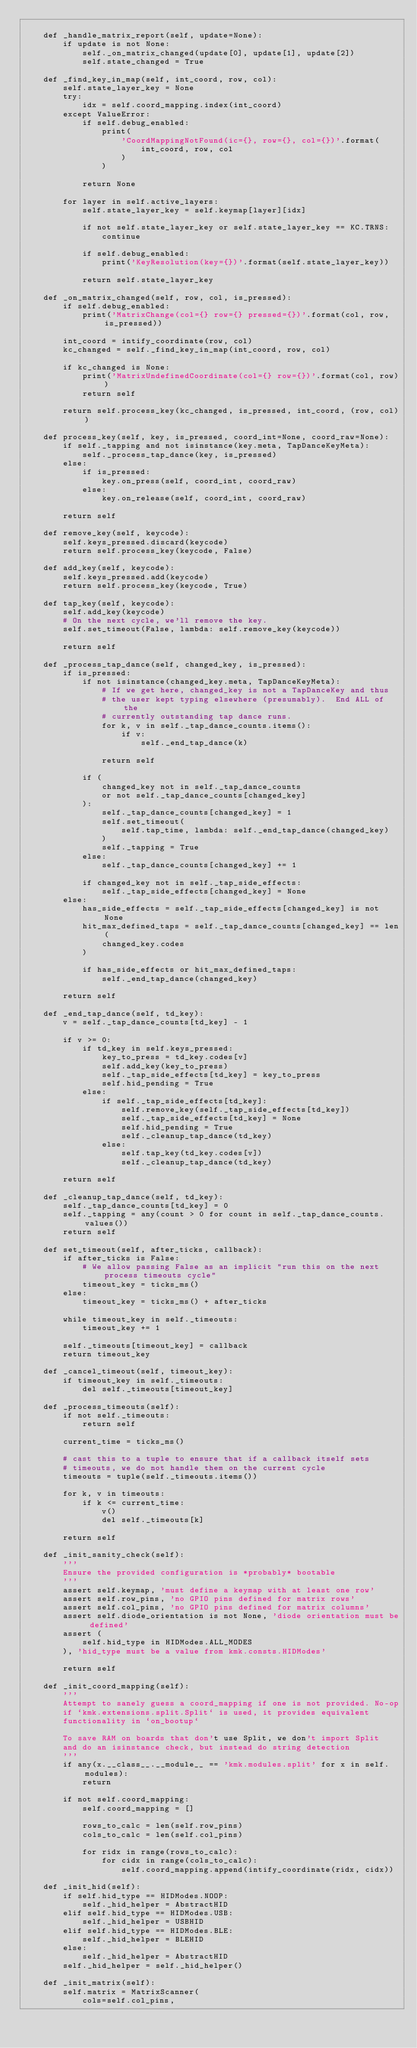Convert code to text. <code><loc_0><loc_0><loc_500><loc_500><_Python_>
    def _handle_matrix_report(self, update=None):
        if update is not None:
            self._on_matrix_changed(update[0], update[1], update[2])
            self.state_changed = True

    def _find_key_in_map(self, int_coord, row, col):
        self.state_layer_key = None
        try:
            idx = self.coord_mapping.index(int_coord)
        except ValueError:
            if self.debug_enabled:
                print(
                    'CoordMappingNotFound(ic={}, row={}, col={})'.format(
                        int_coord, row, col
                    )
                )

            return None

        for layer in self.active_layers:
            self.state_layer_key = self.keymap[layer][idx]

            if not self.state_layer_key or self.state_layer_key == KC.TRNS:
                continue

            if self.debug_enabled:
                print('KeyResolution(key={})'.format(self.state_layer_key))

            return self.state_layer_key

    def _on_matrix_changed(self, row, col, is_pressed):
        if self.debug_enabled:
            print('MatrixChange(col={} row={} pressed={})'.format(col, row, is_pressed))

        int_coord = intify_coordinate(row, col)
        kc_changed = self._find_key_in_map(int_coord, row, col)

        if kc_changed is None:
            print('MatrixUndefinedCoordinate(col={} row={})'.format(col, row))
            return self

        return self.process_key(kc_changed, is_pressed, int_coord, (row, col))

    def process_key(self, key, is_pressed, coord_int=None, coord_raw=None):
        if self._tapping and not isinstance(key.meta, TapDanceKeyMeta):
            self._process_tap_dance(key, is_pressed)
        else:
            if is_pressed:
                key.on_press(self, coord_int, coord_raw)
            else:
                key.on_release(self, coord_int, coord_raw)

        return self

    def remove_key(self, keycode):
        self.keys_pressed.discard(keycode)
        return self.process_key(keycode, False)

    def add_key(self, keycode):
        self.keys_pressed.add(keycode)
        return self.process_key(keycode, True)

    def tap_key(self, keycode):
        self.add_key(keycode)
        # On the next cycle, we'll remove the key.
        self.set_timeout(False, lambda: self.remove_key(keycode))

        return self

    def _process_tap_dance(self, changed_key, is_pressed):
        if is_pressed:
            if not isinstance(changed_key.meta, TapDanceKeyMeta):
                # If we get here, changed_key is not a TapDanceKey and thus
                # the user kept typing elsewhere (presumably).  End ALL of the
                # currently outstanding tap dance runs.
                for k, v in self._tap_dance_counts.items():
                    if v:
                        self._end_tap_dance(k)

                return self

            if (
                changed_key not in self._tap_dance_counts
                or not self._tap_dance_counts[changed_key]
            ):
                self._tap_dance_counts[changed_key] = 1
                self.set_timeout(
                    self.tap_time, lambda: self._end_tap_dance(changed_key)
                )
                self._tapping = True
            else:
                self._tap_dance_counts[changed_key] += 1

            if changed_key not in self._tap_side_effects:
                self._tap_side_effects[changed_key] = None
        else:
            has_side_effects = self._tap_side_effects[changed_key] is not None
            hit_max_defined_taps = self._tap_dance_counts[changed_key] == len(
                changed_key.codes
            )

            if has_side_effects or hit_max_defined_taps:
                self._end_tap_dance(changed_key)

        return self

    def _end_tap_dance(self, td_key):
        v = self._tap_dance_counts[td_key] - 1

        if v >= 0:
            if td_key in self.keys_pressed:
                key_to_press = td_key.codes[v]
                self.add_key(key_to_press)
                self._tap_side_effects[td_key] = key_to_press
                self.hid_pending = True
            else:
                if self._tap_side_effects[td_key]:
                    self.remove_key(self._tap_side_effects[td_key])
                    self._tap_side_effects[td_key] = None
                    self.hid_pending = True
                    self._cleanup_tap_dance(td_key)
                else:
                    self.tap_key(td_key.codes[v])
                    self._cleanup_tap_dance(td_key)

        return self

    def _cleanup_tap_dance(self, td_key):
        self._tap_dance_counts[td_key] = 0
        self._tapping = any(count > 0 for count in self._tap_dance_counts.values())
        return self

    def set_timeout(self, after_ticks, callback):
        if after_ticks is False:
            # We allow passing False as an implicit "run this on the next process timeouts cycle"
            timeout_key = ticks_ms()
        else:
            timeout_key = ticks_ms() + after_ticks

        while timeout_key in self._timeouts:
            timeout_key += 1

        self._timeouts[timeout_key] = callback
        return timeout_key

    def _cancel_timeout(self, timeout_key):
        if timeout_key in self._timeouts:
            del self._timeouts[timeout_key]

    def _process_timeouts(self):
        if not self._timeouts:
            return self

        current_time = ticks_ms()

        # cast this to a tuple to ensure that if a callback itself sets
        # timeouts, we do not handle them on the current cycle
        timeouts = tuple(self._timeouts.items())

        for k, v in timeouts:
            if k <= current_time:
                v()
                del self._timeouts[k]

        return self

    def _init_sanity_check(self):
        '''
        Ensure the provided configuration is *probably* bootable
        '''
        assert self.keymap, 'must define a keymap with at least one row'
        assert self.row_pins, 'no GPIO pins defined for matrix rows'
        assert self.col_pins, 'no GPIO pins defined for matrix columns'
        assert self.diode_orientation is not None, 'diode orientation must be defined'
        assert (
            self.hid_type in HIDModes.ALL_MODES
        ), 'hid_type must be a value from kmk.consts.HIDModes'

        return self

    def _init_coord_mapping(self):
        '''
        Attempt to sanely guess a coord_mapping if one is not provided. No-op
        if `kmk.extensions.split.Split` is used, it provides equivalent
        functionality in `on_bootup`

        To save RAM on boards that don't use Split, we don't import Split
        and do an isinstance check, but instead do string detection
        '''
        if any(x.__class__.__module__ == 'kmk.modules.split' for x in self.modules):
            return

        if not self.coord_mapping:
            self.coord_mapping = []

            rows_to_calc = len(self.row_pins)
            cols_to_calc = len(self.col_pins)

            for ridx in range(rows_to_calc):
                for cidx in range(cols_to_calc):
                    self.coord_mapping.append(intify_coordinate(ridx, cidx))

    def _init_hid(self):
        if self.hid_type == HIDModes.NOOP:
            self._hid_helper = AbstractHID
        elif self.hid_type == HIDModes.USB:
            self._hid_helper = USBHID
        elif self.hid_type == HIDModes.BLE:
            self._hid_helper = BLEHID
        else:
            self._hid_helper = AbstractHID
        self._hid_helper = self._hid_helper()

    def _init_matrix(self):
        self.matrix = MatrixScanner(
            cols=self.col_pins,</code> 